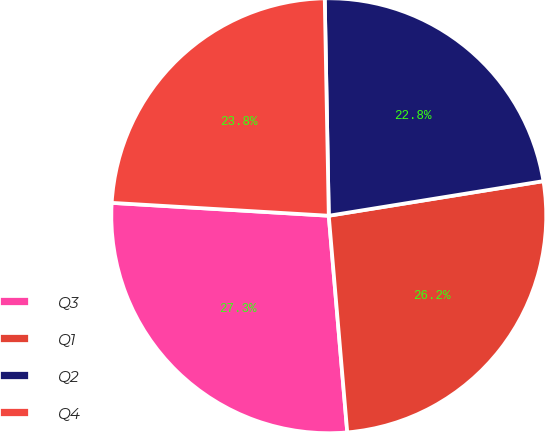<chart> <loc_0><loc_0><loc_500><loc_500><pie_chart><fcel>Q3<fcel>Q1<fcel>Q2<fcel>Q4<nl><fcel>27.3%<fcel>26.19%<fcel>22.75%<fcel>23.76%<nl></chart> 